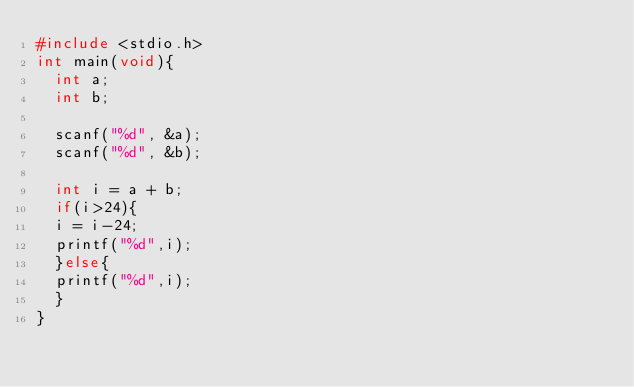Convert code to text. <code><loc_0><loc_0><loc_500><loc_500><_C_>#include <stdio.h>
int main(void){
  int a;
  int b;

  scanf("%d", &a);
  scanf("%d", &b);
  
  int i = a + b;
  if(i>24){
  i = i-24;
  printf("%d",i);
  }else{
  printf("%d",i);
  }
}</code> 